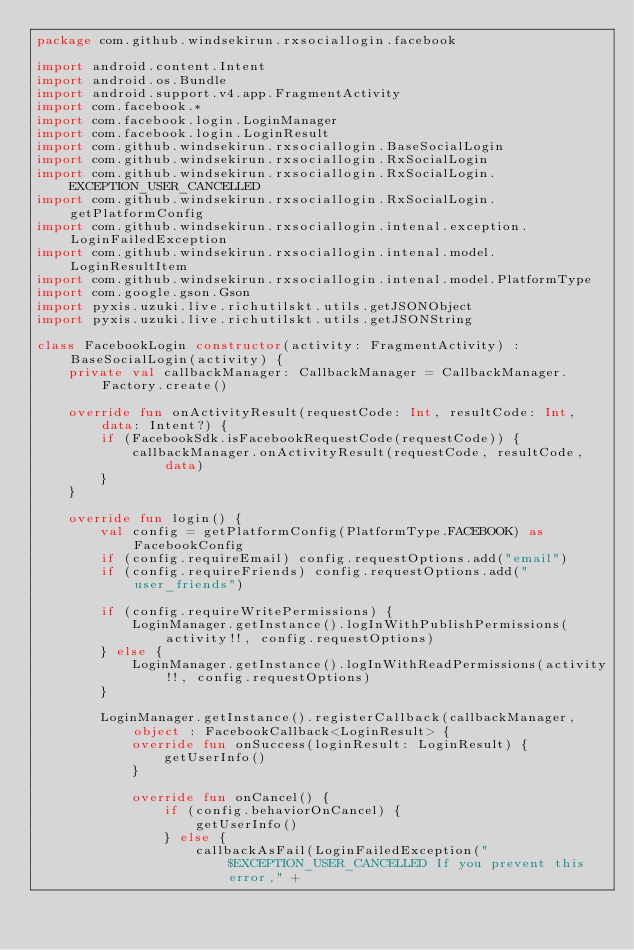Convert code to text. <code><loc_0><loc_0><loc_500><loc_500><_Kotlin_>package com.github.windsekirun.rxsociallogin.facebook

import android.content.Intent
import android.os.Bundle
import android.support.v4.app.FragmentActivity
import com.facebook.*
import com.facebook.login.LoginManager
import com.facebook.login.LoginResult
import com.github.windsekirun.rxsociallogin.BaseSocialLogin
import com.github.windsekirun.rxsociallogin.RxSocialLogin
import com.github.windsekirun.rxsociallogin.RxSocialLogin.EXCEPTION_USER_CANCELLED
import com.github.windsekirun.rxsociallogin.RxSocialLogin.getPlatformConfig
import com.github.windsekirun.rxsociallogin.intenal.exception.LoginFailedException
import com.github.windsekirun.rxsociallogin.intenal.model.LoginResultItem
import com.github.windsekirun.rxsociallogin.intenal.model.PlatformType
import com.google.gson.Gson
import pyxis.uzuki.live.richutilskt.utils.getJSONObject
import pyxis.uzuki.live.richutilskt.utils.getJSONString

class FacebookLogin constructor(activity: FragmentActivity) : BaseSocialLogin(activity) {
    private val callbackManager: CallbackManager = CallbackManager.Factory.create()

    override fun onActivityResult(requestCode: Int, resultCode: Int, data: Intent?) {
        if (FacebookSdk.isFacebookRequestCode(requestCode)) {
            callbackManager.onActivityResult(requestCode, resultCode, data)
        }
    }

    override fun login() {
        val config = getPlatformConfig(PlatformType.FACEBOOK) as FacebookConfig
        if (config.requireEmail) config.requestOptions.add("email")
        if (config.requireFriends) config.requestOptions.add("user_friends")

        if (config.requireWritePermissions) {
            LoginManager.getInstance().logInWithPublishPermissions(activity!!, config.requestOptions)
        } else {
            LoginManager.getInstance().logInWithReadPermissions(activity!!, config.requestOptions)
        }

        LoginManager.getInstance().registerCallback(callbackManager, object : FacebookCallback<LoginResult> {
            override fun onSuccess(loginResult: LoginResult) {
                getUserInfo()
            }

            override fun onCancel() {
                if (config.behaviorOnCancel) {
                    getUserInfo()
                } else {
                    callbackAsFail(LoginFailedException("$EXCEPTION_USER_CANCELLED If you prevent this error," +</code> 